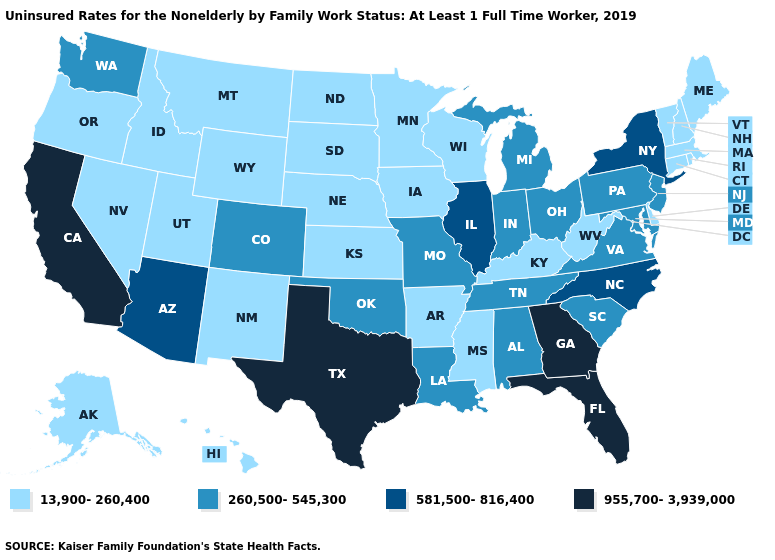What is the value of Maryland?
Give a very brief answer. 260,500-545,300. Does Nevada have the lowest value in the USA?
Concise answer only. Yes. What is the value of Illinois?
Answer briefly. 581,500-816,400. What is the value of Missouri?
Write a very short answer. 260,500-545,300. Name the states that have a value in the range 260,500-545,300?
Be succinct. Alabama, Colorado, Indiana, Louisiana, Maryland, Michigan, Missouri, New Jersey, Ohio, Oklahoma, Pennsylvania, South Carolina, Tennessee, Virginia, Washington. Which states have the lowest value in the USA?
Short answer required. Alaska, Arkansas, Connecticut, Delaware, Hawaii, Idaho, Iowa, Kansas, Kentucky, Maine, Massachusetts, Minnesota, Mississippi, Montana, Nebraska, Nevada, New Hampshire, New Mexico, North Dakota, Oregon, Rhode Island, South Dakota, Utah, Vermont, West Virginia, Wisconsin, Wyoming. What is the value of North Carolina?
Be succinct. 581,500-816,400. Which states have the highest value in the USA?
Concise answer only. California, Florida, Georgia, Texas. Which states have the highest value in the USA?
Write a very short answer. California, Florida, Georgia, Texas. Among the states that border Maine , which have the lowest value?
Concise answer only. New Hampshire. What is the lowest value in the USA?
Give a very brief answer. 13,900-260,400. Among the states that border Mississippi , which have the highest value?
Concise answer only. Alabama, Louisiana, Tennessee. Name the states that have a value in the range 260,500-545,300?
Keep it brief. Alabama, Colorado, Indiana, Louisiana, Maryland, Michigan, Missouri, New Jersey, Ohio, Oklahoma, Pennsylvania, South Carolina, Tennessee, Virginia, Washington. How many symbols are there in the legend?
Write a very short answer. 4. Among the states that border Wisconsin , does Illinois have the highest value?
Answer briefly. Yes. 